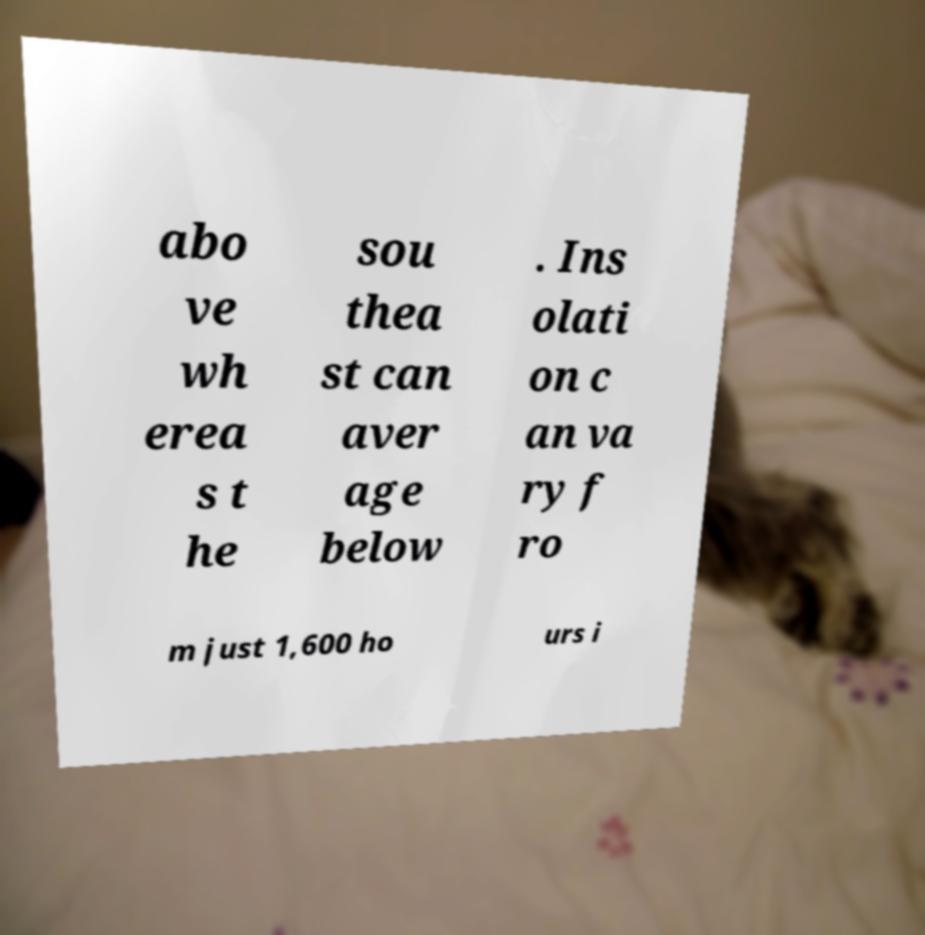Please read and relay the text visible in this image. What does it say? abo ve wh erea s t he sou thea st can aver age below . Ins olati on c an va ry f ro m just 1,600 ho urs i 